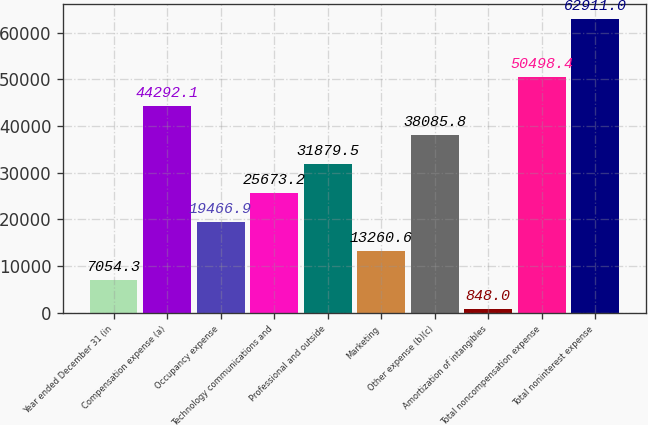Convert chart to OTSL. <chart><loc_0><loc_0><loc_500><loc_500><bar_chart><fcel>Year ended December 31 (in<fcel>Compensation expense (a)<fcel>Occupancy expense<fcel>Technology communications and<fcel>Professional and outside<fcel>Marketing<fcel>Other expense (b)(c)<fcel>Amortization of intangibles<fcel>Total noncompensation expense<fcel>Total noninterest expense<nl><fcel>7054.3<fcel>44292.1<fcel>19466.9<fcel>25673.2<fcel>31879.5<fcel>13260.6<fcel>38085.8<fcel>848<fcel>50498.4<fcel>62911<nl></chart> 